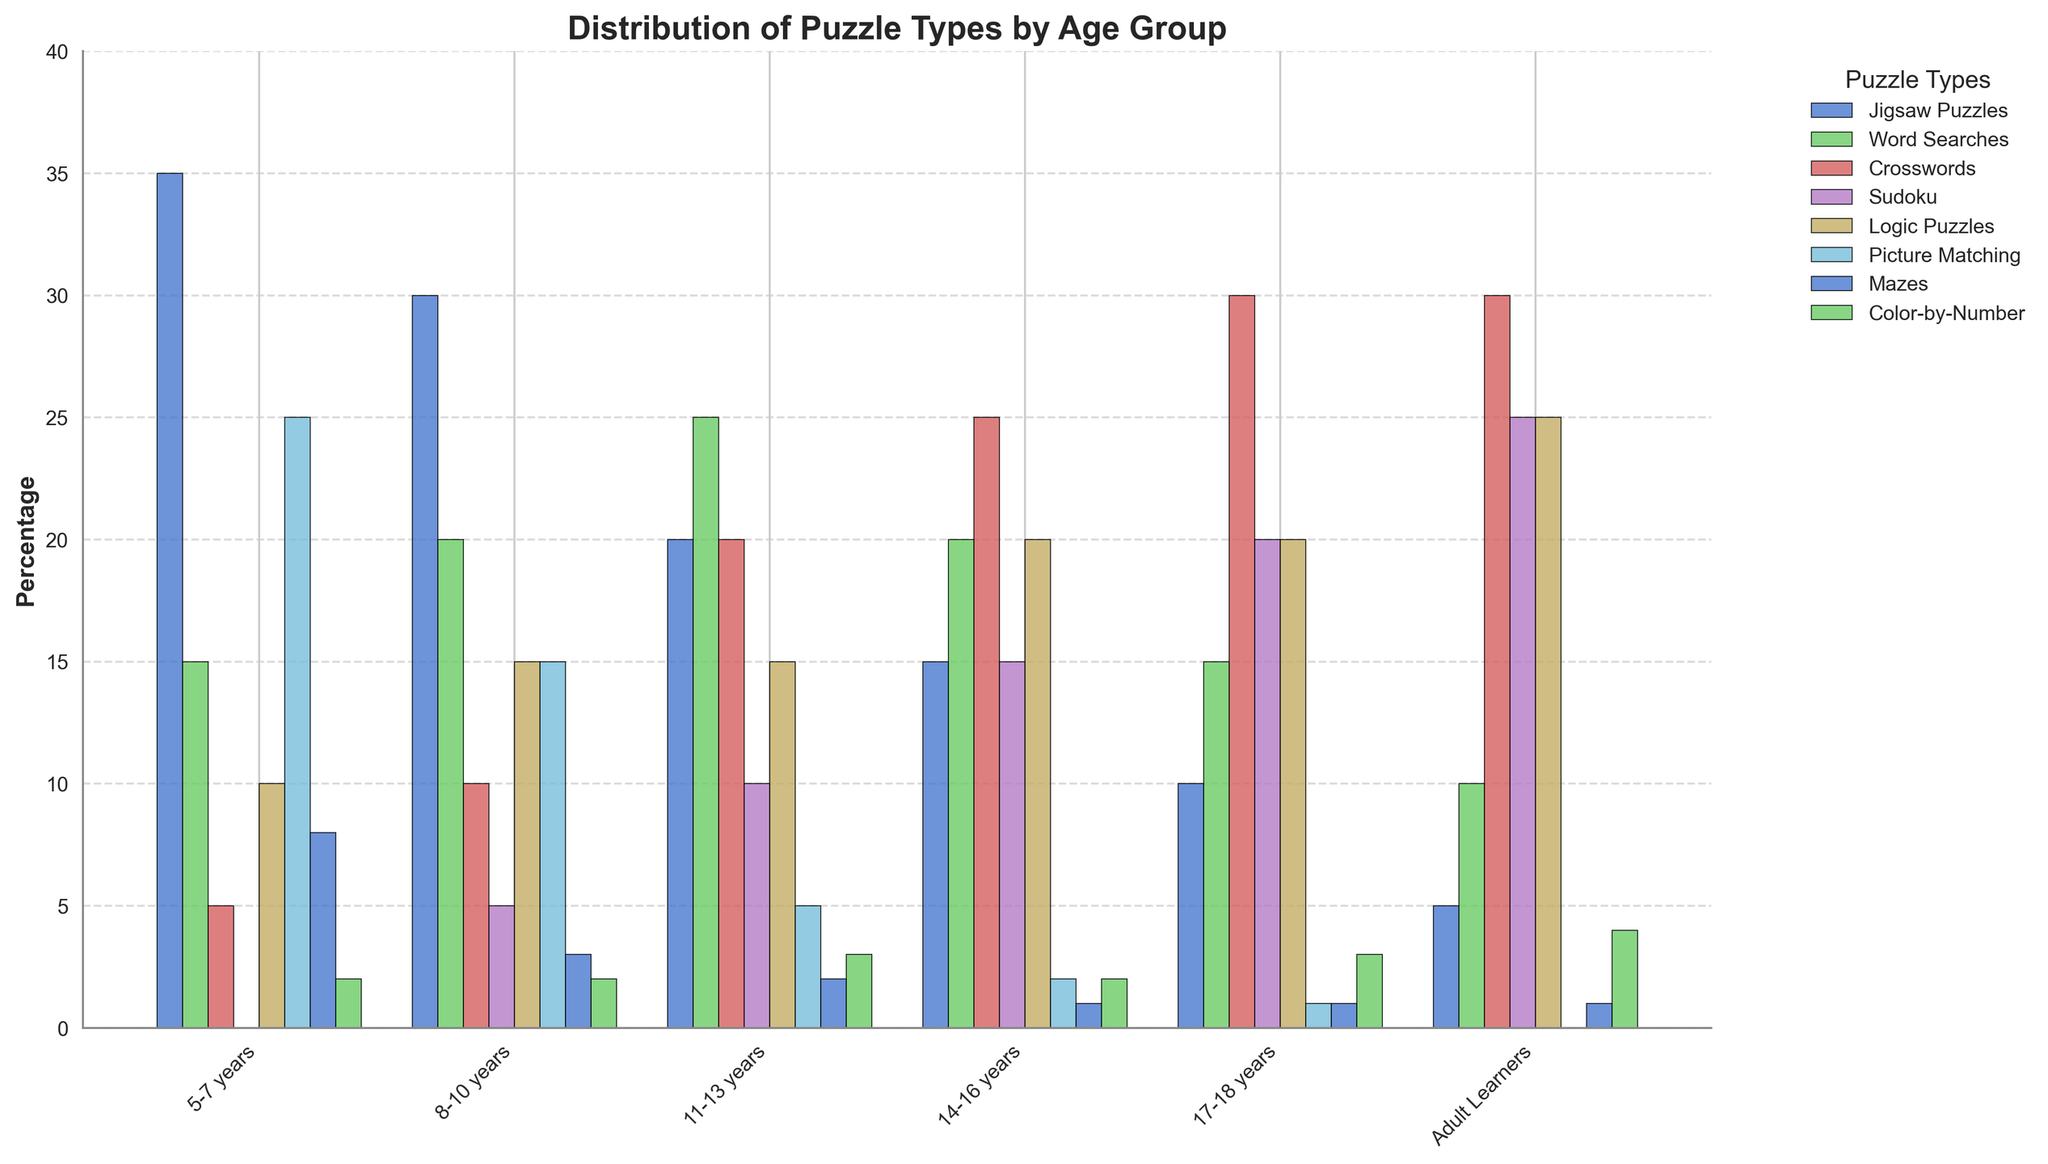Which age group has the highest percentage of Crosswords puzzles? Look at the height of the bars for Crosswords puzzles across the different age groups. The tallest bar is for the "17-18 years" age group.
Answer: 17-18 years What is the total percentage of puzzles for the 8-10 years age group? Sum the percentages of all puzzle types for the 8-10 years age group: 30 + 20 + 10 + 5 + 15 + 15 + 3 + 2 = 100.
Answer: 100 How much greater is the percentage of Sudoku puzzles in the Adult Learners group compared to the 5-7 years group? Subtract the percentage of Sudoku puzzles in the 5-7 years group from that in the Adult Learners group: 25 - 0 = 25.
Answer: 25 Among the age groups, which one has the lowest percentage of Picture Matching puzzles? Look at the heights of the bars for Picture Matching puzzles across all age groups. The lowest bar is for the Adult Learners group.
Answer: Adult Learners Which age group and puzzle type combination stands out the most visually, and why? The combination that stands out the most visually is the high percentage of Jigsaw Puzzles for the 5-7 years age group due to the notably tallest bar in the 5-7 years category.
Answer: 5-7 years, Jigsaw Puzzles What is the sum of percentages of Logic Puzzles for the 14-16 and 17-18 years age groups? Add the percentages of Logic Puzzles for these two age groups: 20 (14-16 years) + 20 (17-18 years) = 40.
Answer: 40 For which age group is the percentage of Word Searches equal to the percentage of Sudoku? Look for the age group where the heights of the bars for Word Searches and Sudoku are the same. This is the 8-10 years group, both at 5%.
Answer: 8-10 years What is the difference in the percentage of Jigsaw Puzzles between the 11-13 years group and the Adult Learners group? Subtract the percentage of Jigsaw Puzzles for the Adult Learners group from that of the 11-13 years group: 20 - 5 = 15.
Answer: 15 How many age groups have a percentage of Mazes that is less than 5%? Identify the age groups with a Maze percentage less than 5%. These are the 11-13 years, 14-16 years, 17-18 years, and Adult Learners groups—4 in total.
Answer: 4 